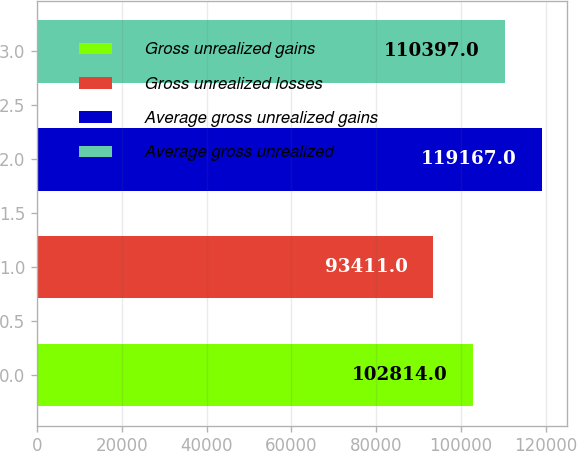Convert chart to OTSL. <chart><loc_0><loc_0><loc_500><loc_500><bar_chart><fcel>Gross unrealized gains<fcel>Gross unrealized losses<fcel>Average gross unrealized gains<fcel>Average gross unrealized<nl><fcel>102814<fcel>93411<fcel>119167<fcel>110397<nl></chart> 